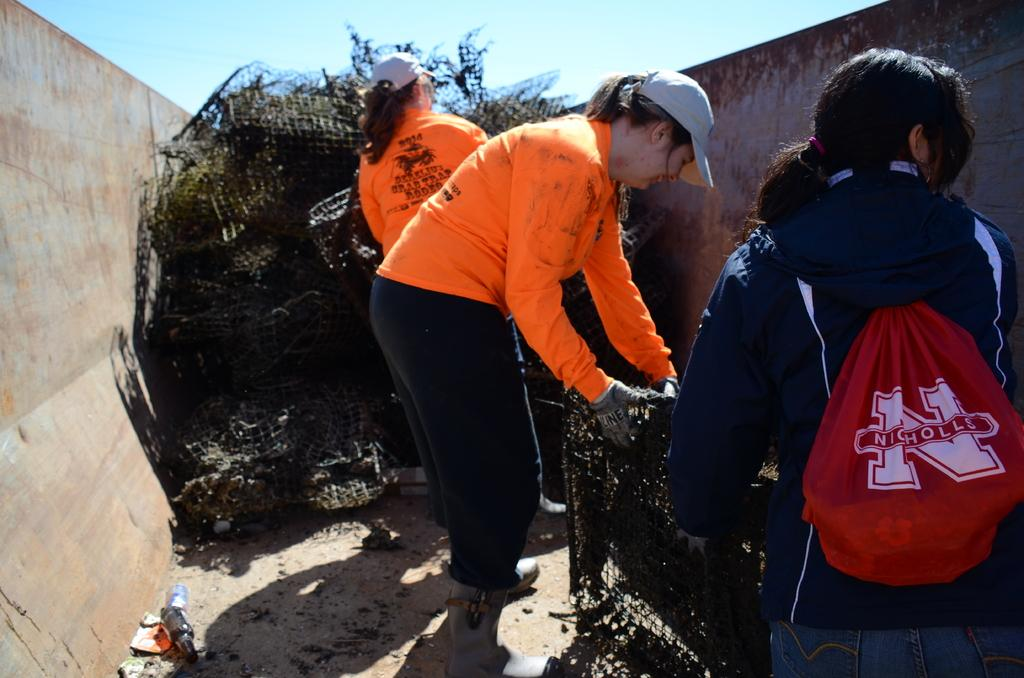How many girls are present in the image? There are three girls in the image. What are the girls wearing? The girls are wearing orange jackets. What are the girls holding in the image? The girls are holding an iron net grill. What can be seen on both sides of the image? There is a wall on both sides of the image. What is visible at the top of the image? The sky is visible at the top of the image. What type of drink is being served at the store in the image? There is no store or drink present in the image. Can you tell me how many kittens are sitting on the wall in the image? There are no kittens present in the image; only the girls, their jackets, the iron net grill, and the walls are visible. 